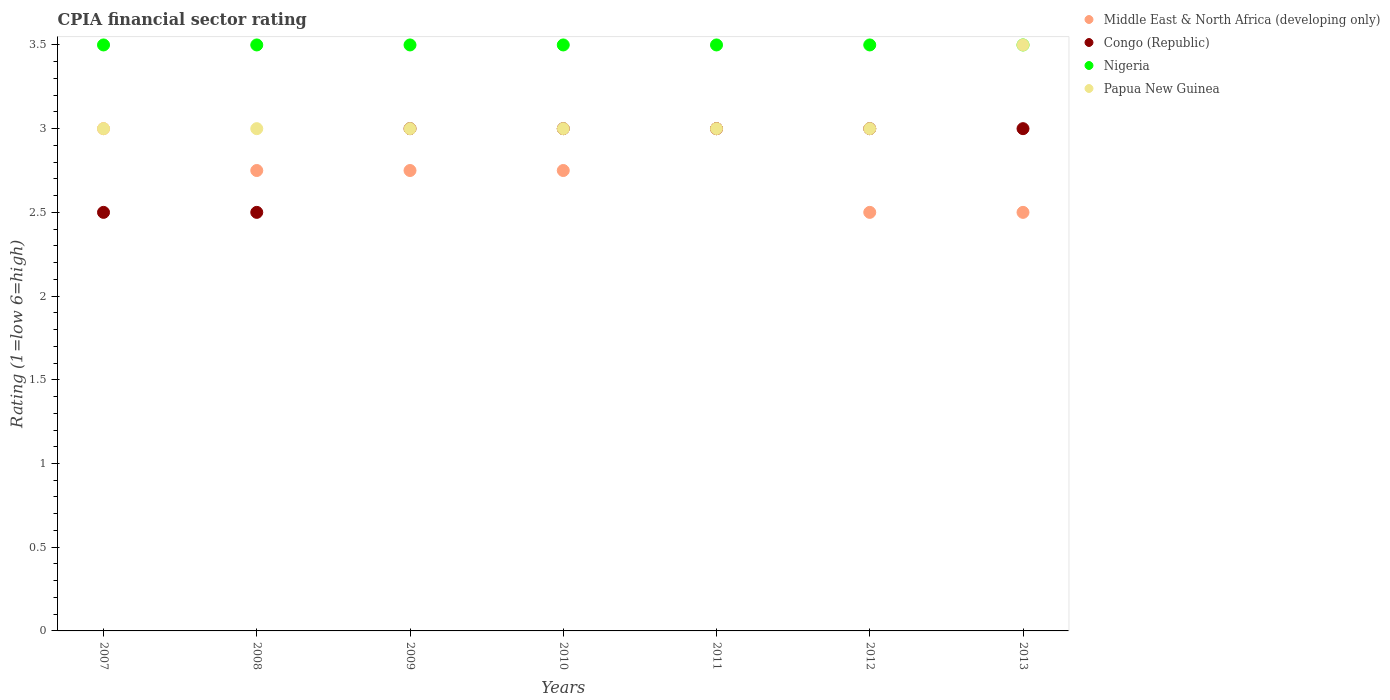Is the number of dotlines equal to the number of legend labels?
Offer a terse response. Yes. In which year was the CPIA rating in Papua New Guinea maximum?
Offer a terse response. 2013. In which year was the CPIA rating in Nigeria minimum?
Offer a very short reply. 2007. What is the difference between the CPIA rating in Congo (Republic) in 2009 and that in 2013?
Offer a very short reply. 0. What is the difference between the CPIA rating in Nigeria in 2009 and the CPIA rating in Middle East & North Africa (developing only) in 2010?
Give a very brief answer. 0.75. What is the average CPIA rating in Middle East & North Africa (developing only) per year?
Make the answer very short. 2.75. Is the CPIA rating in Nigeria in 2008 less than that in 2012?
Your answer should be very brief. No. Is the difference between the CPIA rating in Congo (Republic) in 2007 and 2012 greater than the difference between the CPIA rating in Papua New Guinea in 2007 and 2012?
Offer a very short reply. No. Is the CPIA rating in Middle East & North Africa (developing only) strictly greater than the CPIA rating in Papua New Guinea over the years?
Provide a succinct answer. No. How many dotlines are there?
Offer a terse response. 4. Are the values on the major ticks of Y-axis written in scientific E-notation?
Ensure brevity in your answer.  No. Does the graph contain any zero values?
Offer a terse response. No. Where does the legend appear in the graph?
Your answer should be compact. Top right. How many legend labels are there?
Keep it short and to the point. 4. What is the title of the graph?
Give a very brief answer. CPIA financial sector rating. What is the Rating (1=low 6=high) of Middle East & North Africa (developing only) in 2007?
Provide a succinct answer. 3. What is the Rating (1=low 6=high) of Middle East & North Africa (developing only) in 2008?
Offer a terse response. 2.75. What is the Rating (1=low 6=high) in Nigeria in 2008?
Give a very brief answer. 3.5. What is the Rating (1=low 6=high) of Middle East & North Africa (developing only) in 2009?
Keep it short and to the point. 2.75. What is the Rating (1=low 6=high) in Nigeria in 2009?
Your answer should be very brief. 3.5. What is the Rating (1=low 6=high) of Papua New Guinea in 2009?
Offer a terse response. 3. What is the Rating (1=low 6=high) of Middle East & North Africa (developing only) in 2010?
Your answer should be very brief. 2.75. What is the Rating (1=low 6=high) of Congo (Republic) in 2010?
Offer a very short reply. 3. What is the Rating (1=low 6=high) of Nigeria in 2010?
Offer a very short reply. 3.5. What is the Rating (1=low 6=high) of Papua New Guinea in 2010?
Your answer should be compact. 3. What is the Rating (1=low 6=high) of Congo (Republic) in 2011?
Offer a terse response. 3. What is the Rating (1=low 6=high) of Nigeria in 2011?
Provide a succinct answer. 3.5. What is the Rating (1=low 6=high) of Papua New Guinea in 2011?
Ensure brevity in your answer.  3. What is the Rating (1=low 6=high) of Middle East & North Africa (developing only) in 2012?
Provide a succinct answer. 2.5. What is the Rating (1=low 6=high) of Nigeria in 2012?
Offer a terse response. 3.5. What is the Rating (1=low 6=high) of Papua New Guinea in 2012?
Give a very brief answer. 3. What is the Rating (1=low 6=high) in Papua New Guinea in 2013?
Give a very brief answer. 3.5. Across all years, what is the maximum Rating (1=low 6=high) of Nigeria?
Provide a succinct answer. 3.5. Across all years, what is the minimum Rating (1=low 6=high) of Middle East & North Africa (developing only)?
Offer a very short reply. 2.5. Across all years, what is the minimum Rating (1=low 6=high) in Congo (Republic)?
Offer a very short reply. 2.5. Across all years, what is the minimum Rating (1=low 6=high) in Nigeria?
Offer a terse response. 3.5. Across all years, what is the minimum Rating (1=low 6=high) of Papua New Guinea?
Provide a succinct answer. 3. What is the total Rating (1=low 6=high) of Middle East & North Africa (developing only) in the graph?
Give a very brief answer. 19.25. What is the total Rating (1=low 6=high) of Papua New Guinea in the graph?
Offer a terse response. 21.5. What is the difference between the Rating (1=low 6=high) of Middle East & North Africa (developing only) in 2007 and that in 2008?
Provide a short and direct response. 0.25. What is the difference between the Rating (1=low 6=high) in Nigeria in 2007 and that in 2008?
Provide a short and direct response. 0. What is the difference between the Rating (1=low 6=high) of Congo (Republic) in 2007 and that in 2009?
Ensure brevity in your answer.  -0.5. What is the difference between the Rating (1=low 6=high) of Middle East & North Africa (developing only) in 2007 and that in 2010?
Offer a very short reply. 0.25. What is the difference between the Rating (1=low 6=high) in Congo (Republic) in 2007 and that in 2010?
Provide a succinct answer. -0.5. What is the difference between the Rating (1=low 6=high) in Nigeria in 2007 and that in 2010?
Provide a succinct answer. 0. What is the difference between the Rating (1=low 6=high) of Papua New Guinea in 2007 and that in 2011?
Keep it short and to the point. 0. What is the difference between the Rating (1=low 6=high) of Middle East & North Africa (developing only) in 2007 and that in 2012?
Offer a terse response. 0.5. What is the difference between the Rating (1=low 6=high) of Papua New Guinea in 2007 and that in 2012?
Offer a very short reply. 0. What is the difference between the Rating (1=low 6=high) of Middle East & North Africa (developing only) in 2007 and that in 2013?
Your answer should be compact. 0.5. What is the difference between the Rating (1=low 6=high) in Congo (Republic) in 2007 and that in 2013?
Your answer should be compact. -0.5. What is the difference between the Rating (1=low 6=high) of Middle East & North Africa (developing only) in 2008 and that in 2009?
Offer a very short reply. 0. What is the difference between the Rating (1=low 6=high) of Congo (Republic) in 2008 and that in 2009?
Give a very brief answer. -0.5. What is the difference between the Rating (1=low 6=high) in Papua New Guinea in 2008 and that in 2009?
Offer a very short reply. 0. What is the difference between the Rating (1=low 6=high) in Congo (Republic) in 2008 and that in 2010?
Your answer should be compact. -0.5. What is the difference between the Rating (1=low 6=high) in Congo (Republic) in 2008 and that in 2011?
Offer a very short reply. -0.5. What is the difference between the Rating (1=low 6=high) of Middle East & North Africa (developing only) in 2008 and that in 2012?
Provide a succinct answer. 0.25. What is the difference between the Rating (1=low 6=high) of Nigeria in 2008 and that in 2012?
Ensure brevity in your answer.  0. What is the difference between the Rating (1=low 6=high) in Middle East & North Africa (developing only) in 2008 and that in 2013?
Keep it short and to the point. 0.25. What is the difference between the Rating (1=low 6=high) in Congo (Republic) in 2008 and that in 2013?
Your answer should be very brief. -0.5. What is the difference between the Rating (1=low 6=high) in Papua New Guinea in 2008 and that in 2013?
Provide a short and direct response. -0.5. What is the difference between the Rating (1=low 6=high) of Middle East & North Africa (developing only) in 2009 and that in 2010?
Provide a short and direct response. 0. What is the difference between the Rating (1=low 6=high) of Nigeria in 2009 and that in 2010?
Provide a short and direct response. 0. What is the difference between the Rating (1=low 6=high) of Papua New Guinea in 2009 and that in 2010?
Provide a short and direct response. 0. What is the difference between the Rating (1=low 6=high) of Middle East & North Africa (developing only) in 2009 and that in 2011?
Offer a terse response. -0.25. What is the difference between the Rating (1=low 6=high) of Congo (Republic) in 2009 and that in 2011?
Make the answer very short. 0. What is the difference between the Rating (1=low 6=high) of Nigeria in 2009 and that in 2011?
Offer a terse response. 0. What is the difference between the Rating (1=low 6=high) of Middle East & North Africa (developing only) in 2009 and that in 2012?
Your answer should be very brief. 0.25. What is the difference between the Rating (1=low 6=high) of Papua New Guinea in 2009 and that in 2012?
Keep it short and to the point. 0. What is the difference between the Rating (1=low 6=high) in Congo (Republic) in 2009 and that in 2013?
Give a very brief answer. 0. What is the difference between the Rating (1=low 6=high) in Nigeria in 2009 and that in 2013?
Offer a terse response. 0. What is the difference between the Rating (1=low 6=high) of Papua New Guinea in 2009 and that in 2013?
Ensure brevity in your answer.  -0.5. What is the difference between the Rating (1=low 6=high) in Congo (Republic) in 2010 and that in 2011?
Give a very brief answer. 0. What is the difference between the Rating (1=low 6=high) in Papua New Guinea in 2010 and that in 2011?
Provide a succinct answer. 0. What is the difference between the Rating (1=low 6=high) in Congo (Republic) in 2010 and that in 2012?
Offer a terse response. 0. What is the difference between the Rating (1=low 6=high) of Nigeria in 2010 and that in 2012?
Offer a very short reply. 0. What is the difference between the Rating (1=low 6=high) of Congo (Republic) in 2010 and that in 2013?
Provide a short and direct response. 0. What is the difference between the Rating (1=low 6=high) in Nigeria in 2010 and that in 2013?
Ensure brevity in your answer.  0. What is the difference between the Rating (1=low 6=high) in Papua New Guinea in 2010 and that in 2013?
Keep it short and to the point. -0.5. What is the difference between the Rating (1=low 6=high) of Congo (Republic) in 2011 and that in 2012?
Provide a short and direct response. 0. What is the difference between the Rating (1=low 6=high) in Nigeria in 2011 and that in 2012?
Keep it short and to the point. 0. What is the difference between the Rating (1=low 6=high) in Middle East & North Africa (developing only) in 2011 and that in 2013?
Your answer should be compact. 0.5. What is the difference between the Rating (1=low 6=high) in Congo (Republic) in 2011 and that in 2013?
Offer a terse response. 0. What is the difference between the Rating (1=low 6=high) in Papua New Guinea in 2011 and that in 2013?
Your answer should be very brief. -0.5. What is the difference between the Rating (1=low 6=high) of Congo (Republic) in 2012 and that in 2013?
Provide a succinct answer. 0. What is the difference between the Rating (1=low 6=high) in Congo (Republic) in 2007 and the Rating (1=low 6=high) in Nigeria in 2008?
Offer a very short reply. -1. What is the difference between the Rating (1=low 6=high) in Congo (Republic) in 2007 and the Rating (1=low 6=high) in Papua New Guinea in 2008?
Offer a terse response. -0.5. What is the difference between the Rating (1=low 6=high) in Middle East & North Africa (developing only) in 2007 and the Rating (1=low 6=high) in Congo (Republic) in 2009?
Your answer should be very brief. 0. What is the difference between the Rating (1=low 6=high) of Middle East & North Africa (developing only) in 2007 and the Rating (1=low 6=high) of Nigeria in 2009?
Give a very brief answer. -0.5. What is the difference between the Rating (1=low 6=high) of Middle East & North Africa (developing only) in 2007 and the Rating (1=low 6=high) of Papua New Guinea in 2009?
Offer a terse response. 0. What is the difference between the Rating (1=low 6=high) of Congo (Republic) in 2007 and the Rating (1=low 6=high) of Nigeria in 2009?
Make the answer very short. -1. What is the difference between the Rating (1=low 6=high) of Middle East & North Africa (developing only) in 2007 and the Rating (1=low 6=high) of Nigeria in 2010?
Provide a short and direct response. -0.5. What is the difference between the Rating (1=low 6=high) in Middle East & North Africa (developing only) in 2007 and the Rating (1=low 6=high) in Papua New Guinea in 2010?
Give a very brief answer. 0. What is the difference between the Rating (1=low 6=high) in Congo (Republic) in 2007 and the Rating (1=low 6=high) in Nigeria in 2010?
Ensure brevity in your answer.  -1. What is the difference between the Rating (1=low 6=high) in Nigeria in 2007 and the Rating (1=low 6=high) in Papua New Guinea in 2010?
Ensure brevity in your answer.  0.5. What is the difference between the Rating (1=low 6=high) of Middle East & North Africa (developing only) in 2007 and the Rating (1=low 6=high) of Congo (Republic) in 2011?
Your answer should be compact. 0. What is the difference between the Rating (1=low 6=high) of Middle East & North Africa (developing only) in 2007 and the Rating (1=low 6=high) of Nigeria in 2011?
Provide a short and direct response. -0.5. What is the difference between the Rating (1=low 6=high) in Middle East & North Africa (developing only) in 2007 and the Rating (1=low 6=high) in Papua New Guinea in 2011?
Your answer should be very brief. 0. What is the difference between the Rating (1=low 6=high) in Congo (Republic) in 2007 and the Rating (1=low 6=high) in Papua New Guinea in 2011?
Provide a succinct answer. -0.5. What is the difference between the Rating (1=low 6=high) in Middle East & North Africa (developing only) in 2007 and the Rating (1=low 6=high) in Congo (Republic) in 2012?
Provide a short and direct response. 0. What is the difference between the Rating (1=low 6=high) in Middle East & North Africa (developing only) in 2007 and the Rating (1=low 6=high) in Nigeria in 2012?
Ensure brevity in your answer.  -0.5. What is the difference between the Rating (1=low 6=high) in Congo (Republic) in 2007 and the Rating (1=low 6=high) in Nigeria in 2012?
Offer a terse response. -1. What is the difference between the Rating (1=low 6=high) of Nigeria in 2007 and the Rating (1=low 6=high) of Papua New Guinea in 2012?
Provide a succinct answer. 0.5. What is the difference between the Rating (1=low 6=high) in Middle East & North Africa (developing only) in 2007 and the Rating (1=low 6=high) in Congo (Republic) in 2013?
Keep it short and to the point. 0. What is the difference between the Rating (1=low 6=high) of Middle East & North Africa (developing only) in 2007 and the Rating (1=low 6=high) of Nigeria in 2013?
Ensure brevity in your answer.  -0.5. What is the difference between the Rating (1=low 6=high) of Middle East & North Africa (developing only) in 2007 and the Rating (1=low 6=high) of Papua New Guinea in 2013?
Offer a very short reply. -0.5. What is the difference between the Rating (1=low 6=high) in Congo (Republic) in 2007 and the Rating (1=low 6=high) in Papua New Guinea in 2013?
Your answer should be very brief. -1. What is the difference between the Rating (1=low 6=high) in Middle East & North Africa (developing only) in 2008 and the Rating (1=low 6=high) in Nigeria in 2009?
Your answer should be very brief. -0.75. What is the difference between the Rating (1=low 6=high) in Congo (Republic) in 2008 and the Rating (1=low 6=high) in Nigeria in 2009?
Offer a very short reply. -1. What is the difference between the Rating (1=low 6=high) in Nigeria in 2008 and the Rating (1=low 6=high) in Papua New Guinea in 2009?
Your answer should be very brief. 0.5. What is the difference between the Rating (1=low 6=high) in Middle East & North Africa (developing only) in 2008 and the Rating (1=low 6=high) in Congo (Republic) in 2010?
Keep it short and to the point. -0.25. What is the difference between the Rating (1=low 6=high) of Middle East & North Africa (developing only) in 2008 and the Rating (1=low 6=high) of Nigeria in 2010?
Make the answer very short. -0.75. What is the difference between the Rating (1=low 6=high) of Middle East & North Africa (developing only) in 2008 and the Rating (1=low 6=high) of Papua New Guinea in 2010?
Make the answer very short. -0.25. What is the difference between the Rating (1=low 6=high) in Congo (Republic) in 2008 and the Rating (1=low 6=high) in Papua New Guinea in 2010?
Your response must be concise. -0.5. What is the difference between the Rating (1=low 6=high) of Nigeria in 2008 and the Rating (1=low 6=high) of Papua New Guinea in 2010?
Offer a very short reply. 0.5. What is the difference between the Rating (1=low 6=high) of Middle East & North Africa (developing only) in 2008 and the Rating (1=low 6=high) of Congo (Republic) in 2011?
Offer a very short reply. -0.25. What is the difference between the Rating (1=low 6=high) in Middle East & North Africa (developing only) in 2008 and the Rating (1=low 6=high) in Nigeria in 2011?
Your answer should be very brief. -0.75. What is the difference between the Rating (1=low 6=high) of Congo (Republic) in 2008 and the Rating (1=low 6=high) of Nigeria in 2011?
Provide a short and direct response. -1. What is the difference between the Rating (1=low 6=high) of Middle East & North Africa (developing only) in 2008 and the Rating (1=low 6=high) of Congo (Republic) in 2012?
Keep it short and to the point. -0.25. What is the difference between the Rating (1=low 6=high) in Middle East & North Africa (developing only) in 2008 and the Rating (1=low 6=high) in Nigeria in 2012?
Keep it short and to the point. -0.75. What is the difference between the Rating (1=low 6=high) of Middle East & North Africa (developing only) in 2008 and the Rating (1=low 6=high) of Papua New Guinea in 2012?
Ensure brevity in your answer.  -0.25. What is the difference between the Rating (1=low 6=high) in Middle East & North Africa (developing only) in 2008 and the Rating (1=low 6=high) in Congo (Republic) in 2013?
Provide a succinct answer. -0.25. What is the difference between the Rating (1=low 6=high) in Middle East & North Africa (developing only) in 2008 and the Rating (1=low 6=high) in Nigeria in 2013?
Offer a very short reply. -0.75. What is the difference between the Rating (1=low 6=high) of Middle East & North Africa (developing only) in 2008 and the Rating (1=low 6=high) of Papua New Guinea in 2013?
Provide a succinct answer. -0.75. What is the difference between the Rating (1=low 6=high) in Congo (Republic) in 2008 and the Rating (1=low 6=high) in Nigeria in 2013?
Offer a very short reply. -1. What is the difference between the Rating (1=low 6=high) of Congo (Republic) in 2008 and the Rating (1=low 6=high) of Papua New Guinea in 2013?
Provide a short and direct response. -1. What is the difference between the Rating (1=low 6=high) of Nigeria in 2008 and the Rating (1=low 6=high) of Papua New Guinea in 2013?
Provide a short and direct response. 0. What is the difference between the Rating (1=low 6=high) of Middle East & North Africa (developing only) in 2009 and the Rating (1=low 6=high) of Nigeria in 2010?
Ensure brevity in your answer.  -0.75. What is the difference between the Rating (1=low 6=high) of Congo (Republic) in 2009 and the Rating (1=low 6=high) of Papua New Guinea in 2010?
Make the answer very short. 0. What is the difference between the Rating (1=low 6=high) of Middle East & North Africa (developing only) in 2009 and the Rating (1=low 6=high) of Congo (Republic) in 2011?
Make the answer very short. -0.25. What is the difference between the Rating (1=low 6=high) in Middle East & North Africa (developing only) in 2009 and the Rating (1=low 6=high) in Nigeria in 2011?
Your response must be concise. -0.75. What is the difference between the Rating (1=low 6=high) of Middle East & North Africa (developing only) in 2009 and the Rating (1=low 6=high) of Congo (Republic) in 2012?
Ensure brevity in your answer.  -0.25. What is the difference between the Rating (1=low 6=high) in Middle East & North Africa (developing only) in 2009 and the Rating (1=low 6=high) in Nigeria in 2012?
Give a very brief answer. -0.75. What is the difference between the Rating (1=low 6=high) of Middle East & North Africa (developing only) in 2009 and the Rating (1=low 6=high) of Nigeria in 2013?
Make the answer very short. -0.75. What is the difference between the Rating (1=low 6=high) in Middle East & North Africa (developing only) in 2009 and the Rating (1=low 6=high) in Papua New Guinea in 2013?
Offer a terse response. -0.75. What is the difference between the Rating (1=low 6=high) of Congo (Republic) in 2009 and the Rating (1=low 6=high) of Nigeria in 2013?
Your response must be concise. -0.5. What is the difference between the Rating (1=low 6=high) in Congo (Republic) in 2009 and the Rating (1=low 6=high) in Papua New Guinea in 2013?
Ensure brevity in your answer.  -0.5. What is the difference between the Rating (1=low 6=high) of Nigeria in 2009 and the Rating (1=low 6=high) of Papua New Guinea in 2013?
Your answer should be very brief. 0. What is the difference between the Rating (1=low 6=high) of Middle East & North Africa (developing only) in 2010 and the Rating (1=low 6=high) of Nigeria in 2011?
Your answer should be very brief. -0.75. What is the difference between the Rating (1=low 6=high) of Congo (Republic) in 2010 and the Rating (1=low 6=high) of Nigeria in 2011?
Keep it short and to the point. -0.5. What is the difference between the Rating (1=low 6=high) of Middle East & North Africa (developing only) in 2010 and the Rating (1=low 6=high) of Nigeria in 2012?
Your answer should be very brief. -0.75. What is the difference between the Rating (1=low 6=high) in Congo (Republic) in 2010 and the Rating (1=low 6=high) in Papua New Guinea in 2012?
Offer a very short reply. 0. What is the difference between the Rating (1=low 6=high) in Middle East & North Africa (developing only) in 2010 and the Rating (1=low 6=high) in Nigeria in 2013?
Your answer should be very brief. -0.75. What is the difference between the Rating (1=low 6=high) of Middle East & North Africa (developing only) in 2010 and the Rating (1=low 6=high) of Papua New Guinea in 2013?
Make the answer very short. -0.75. What is the difference between the Rating (1=low 6=high) in Congo (Republic) in 2010 and the Rating (1=low 6=high) in Papua New Guinea in 2013?
Your response must be concise. -0.5. What is the difference between the Rating (1=low 6=high) in Middle East & North Africa (developing only) in 2011 and the Rating (1=low 6=high) in Congo (Republic) in 2012?
Ensure brevity in your answer.  0. What is the difference between the Rating (1=low 6=high) in Middle East & North Africa (developing only) in 2011 and the Rating (1=low 6=high) in Nigeria in 2012?
Your answer should be very brief. -0.5. What is the difference between the Rating (1=low 6=high) in Congo (Republic) in 2011 and the Rating (1=low 6=high) in Papua New Guinea in 2012?
Give a very brief answer. 0. What is the difference between the Rating (1=low 6=high) in Nigeria in 2011 and the Rating (1=low 6=high) in Papua New Guinea in 2012?
Provide a short and direct response. 0.5. What is the difference between the Rating (1=low 6=high) of Middle East & North Africa (developing only) in 2011 and the Rating (1=low 6=high) of Papua New Guinea in 2013?
Your answer should be compact. -0.5. What is the difference between the Rating (1=low 6=high) of Congo (Republic) in 2011 and the Rating (1=low 6=high) of Nigeria in 2013?
Ensure brevity in your answer.  -0.5. What is the difference between the Rating (1=low 6=high) in Congo (Republic) in 2011 and the Rating (1=low 6=high) in Papua New Guinea in 2013?
Your response must be concise. -0.5. What is the difference between the Rating (1=low 6=high) in Nigeria in 2011 and the Rating (1=low 6=high) in Papua New Guinea in 2013?
Offer a very short reply. 0. What is the difference between the Rating (1=low 6=high) in Middle East & North Africa (developing only) in 2012 and the Rating (1=low 6=high) in Congo (Republic) in 2013?
Offer a very short reply. -0.5. What is the difference between the Rating (1=low 6=high) in Middle East & North Africa (developing only) in 2012 and the Rating (1=low 6=high) in Papua New Guinea in 2013?
Your answer should be very brief. -1. What is the difference between the Rating (1=low 6=high) of Congo (Republic) in 2012 and the Rating (1=low 6=high) of Papua New Guinea in 2013?
Ensure brevity in your answer.  -0.5. What is the average Rating (1=low 6=high) of Middle East & North Africa (developing only) per year?
Keep it short and to the point. 2.75. What is the average Rating (1=low 6=high) in Congo (Republic) per year?
Keep it short and to the point. 2.86. What is the average Rating (1=low 6=high) in Nigeria per year?
Your answer should be compact. 3.5. What is the average Rating (1=low 6=high) in Papua New Guinea per year?
Provide a succinct answer. 3.07. In the year 2007, what is the difference between the Rating (1=low 6=high) of Middle East & North Africa (developing only) and Rating (1=low 6=high) of Congo (Republic)?
Ensure brevity in your answer.  0.5. In the year 2007, what is the difference between the Rating (1=low 6=high) of Congo (Republic) and Rating (1=low 6=high) of Nigeria?
Your answer should be compact. -1. In the year 2007, what is the difference between the Rating (1=low 6=high) of Congo (Republic) and Rating (1=low 6=high) of Papua New Guinea?
Make the answer very short. -0.5. In the year 2007, what is the difference between the Rating (1=low 6=high) in Nigeria and Rating (1=low 6=high) in Papua New Guinea?
Your answer should be compact. 0.5. In the year 2008, what is the difference between the Rating (1=low 6=high) in Middle East & North Africa (developing only) and Rating (1=low 6=high) in Congo (Republic)?
Provide a succinct answer. 0.25. In the year 2008, what is the difference between the Rating (1=low 6=high) of Middle East & North Africa (developing only) and Rating (1=low 6=high) of Nigeria?
Make the answer very short. -0.75. In the year 2008, what is the difference between the Rating (1=low 6=high) of Congo (Republic) and Rating (1=low 6=high) of Nigeria?
Ensure brevity in your answer.  -1. In the year 2008, what is the difference between the Rating (1=low 6=high) in Nigeria and Rating (1=low 6=high) in Papua New Guinea?
Your response must be concise. 0.5. In the year 2009, what is the difference between the Rating (1=low 6=high) of Middle East & North Africa (developing only) and Rating (1=low 6=high) of Congo (Republic)?
Give a very brief answer. -0.25. In the year 2009, what is the difference between the Rating (1=low 6=high) of Middle East & North Africa (developing only) and Rating (1=low 6=high) of Nigeria?
Keep it short and to the point. -0.75. In the year 2009, what is the difference between the Rating (1=low 6=high) of Middle East & North Africa (developing only) and Rating (1=low 6=high) of Papua New Guinea?
Ensure brevity in your answer.  -0.25. In the year 2009, what is the difference between the Rating (1=low 6=high) in Congo (Republic) and Rating (1=low 6=high) in Papua New Guinea?
Give a very brief answer. 0. In the year 2010, what is the difference between the Rating (1=low 6=high) of Middle East & North Africa (developing only) and Rating (1=low 6=high) of Nigeria?
Your response must be concise. -0.75. In the year 2010, what is the difference between the Rating (1=low 6=high) in Middle East & North Africa (developing only) and Rating (1=low 6=high) in Papua New Guinea?
Keep it short and to the point. -0.25. In the year 2010, what is the difference between the Rating (1=low 6=high) of Congo (Republic) and Rating (1=low 6=high) of Nigeria?
Make the answer very short. -0.5. In the year 2010, what is the difference between the Rating (1=low 6=high) of Congo (Republic) and Rating (1=low 6=high) of Papua New Guinea?
Offer a very short reply. 0. In the year 2010, what is the difference between the Rating (1=low 6=high) in Nigeria and Rating (1=low 6=high) in Papua New Guinea?
Offer a terse response. 0.5. In the year 2011, what is the difference between the Rating (1=low 6=high) in Middle East & North Africa (developing only) and Rating (1=low 6=high) in Congo (Republic)?
Offer a very short reply. 0. In the year 2011, what is the difference between the Rating (1=low 6=high) in Middle East & North Africa (developing only) and Rating (1=low 6=high) in Nigeria?
Provide a short and direct response. -0.5. In the year 2011, what is the difference between the Rating (1=low 6=high) in Middle East & North Africa (developing only) and Rating (1=low 6=high) in Papua New Guinea?
Ensure brevity in your answer.  0. In the year 2011, what is the difference between the Rating (1=low 6=high) of Congo (Republic) and Rating (1=low 6=high) of Nigeria?
Provide a succinct answer. -0.5. In the year 2011, what is the difference between the Rating (1=low 6=high) in Nigeria and Rating (1=low 6=high) in Papua New Guinea?
Your response must be concise. 0.5. In the year 2012, what is the difference between the Rating (1=low 6=high) of Middle East & North Africa (developing only) and Rating (1=low 6=high) of Nigeria?
Offer a very short reply. -1. In the year 2013, what is the difference between the Rating (1=low 6=high) in Congo (Republic) and Rating (1=low 6=high) in Papua New Guinea?
Make the answer very short. -0.5. What is the ratio of the Rating (1=low 6=high) of Middle East & North Africa (developing only) in 2007 to that in 2008?
Ensure brevity in your answer.  1.09. What is the ratio of the Rating (1=low 6=high) of Papua New Guinea in 2007 to that in 2008?
Keep it short and to the point. 1. What is the ratio of the Rating (1=low 6=high) of Middle East & North Africa (developing only) in 2007 to that in 2009?
Provide a succinct answer. 1.09. What is the ratio of the Rating (1=low 6=high) in Congo (Republic) in 2007 to that in 2009?
Make the answer very short. 0.83. What is the ratio of the Rating (1=low 6=high) of Papua New Guinea in 2007 to that in 2009?
Your answer should be compact. 1. What is the ratio of the Rating (1=low 6=high) of Nigeria in 2007 to that in 2010?
Make the answer very short. 1. What is the ratio of the Rating (1=low 6=high) in Middle East & North Africa (developing only) in 2007 to that in 2011?
Make the answer very short. 1. What is the ratio of the Rating (1=low 6=high) in Congo (Republic) in 2007 to that in 2011?
Ensure brevity in your answer.  0.83. What is the ratio of the Rating (1=low 6=high) of Nigeria in 2007 to that in 2011?
Your answer should be compact. 1. What is the ratio of the Rating (1=low 6=high) in Nigeria in 2007 to that in 2012?
Keep it short and to the point. 1. What is the ratio of the Rating (1=low 6=high) in Middle East & North Africa (developing only) in 2007 to that in 2013?
Offer a terse response. 1.2. What is the ratio of the Rating (1=low 6=high) in Congo (Republic) in 2007 to that in 2013?
Provide a short and direct response. 0.83. What is the ratio of the Rating (1=low 6=high) of Papua New Guinea in 2007 to that in 2013?
Your answer should be very brief. 0.86. What is the ratio of the Rating (1=low 6=high) of Congo (Republic) in 2008 to that in 2010?
Offer a very short reply. 0.83. What is the ratio of the Rating (1=low 6=high) of Papua New Guinea in 2008 to that in 2010?
Your answer should be compact. 1. What is the ratio of the Rating (1=low 6=high) of Congo (Republic) in 2008 to that in 2011?
Provide a short and direct response. 0.83. What is the ratio of the Rating (1=low 6=high) in Middle East & North Africa (developing only) in 2008 to that in 2013?
Provide a succinct answer. 1.1. What is the ratio of the Rating (1=low 6=high) in Papua New Guinea in 2008 to that in 2013?
Your response must be concise. 0.86. What is the ratio of the Rating (1=low 6=high) in Middle East & North Africa (developing only) in 2009 to that in 2010?
Keep it short and to the point. 1. What is the ratio of the Rating (1=low 6=high) in Papua New Guinea in 2009 to that in 2010?
Provide a short and direct response. 1. What is the ratio of the Rating (1=low 6=high) of Papua New Guinea in 2009 to that in 2011?
Provide a short and direct response. 1. What is the ratio of the Rating (1=low 6=high) in Middle East & North Africa (developing only) in 2009 to that in 2012?
Provide a short and direct response. 1.1. What is the ratio of the Rating (1=low 6=high) in Middle East & North Africa (developing only) in 2009 to that in 2013?
Your answer should be very brief. 1.1. What is the ratio of the Rating (1=low 6=high) of Congo (Republic) in 2009 to that in 2013?
Give a very brief answer. 1. What is the ratio of the Rating (1=low 6=high) of Papua New Guinea in 2009 to that in 2013?
Make the answer very short. 0.86. What is the ratio of the Rating (1=low 6=high) in Congo (Republic) in 2010 to that in 2011?
Give a very brief answer. 1. What is the ratio of the Rating (1=low 6=high) of Middle East & North Africa (developing only) in 2010 to that in 2013?
Give a very brief answer. 1.1. What is the ratio of the Rating (1=low 6=high) of Congo (Republic) in 2010 to that in 2013?
Offer a very short reply. 1. What is the ratio of the Rating (1=low 6=high) of Nigeria in 2010 to that in 2013?
Give a very brief answer. 1. What is the ratio of the Rating (1=low 6=high) of Papua New Guinea in 2010 to that in 2013?
Your answer should be compact. 0.86. What is the ratio of the Rating (1=low 6=high) in Middle East & North Africa (developing only) in 2011 to that in 2012?
Your answer should be compact. 1.2. What is the ratio of the Rating (1=low 6=high) of Middle East & North Africa (developing only) in 2011 to that in 2013?
Keep it short and to the point. 1.2. What is the ratio of the Rating (1=low 6=high) of Congo (Republic) in 2011 to that in 2013?
Your response must be concise. 1. What is the ratio of the Rating (1=low 6=high) of Nigeria in 2011 to that in 2013?
Your response must be concise. 1. What is the difference between the highest and the second highest Rating (1=low 6=high) in Middle East & North Africa (developing only)?
Your answer should be compact. 0. What is the difference between the highest and the second highest Rating (1=low 6=high) in Congo (Republic)?
Provide a succinct answer. 0. What is the difference between the highest and the lowest Rating (1=low 6=high) of Middle East & North Africa (developing only)?
Give a very brief answer. 0.5. 